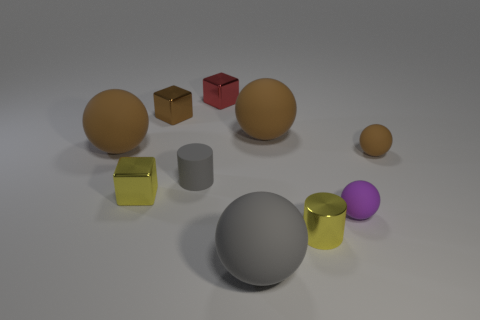There is a big ball that is in front of the small brown matte sphere; does it have the same color as the rubber cylinder?
Make the answer very short. Yes. Are there more tiny brown things on the right side of the yellow metal cylinder than purple rubber objects that are in front of the tiny purple matte ball?
Ensure brevity in your answer.  Yes. Are there any other things that have the same color as the small shiny cylinder?
Your answer should be compact. Yes. How many things are either shiny blocks or large gray matte spheres?
Ensure brevity in your answer.  4. Is the size of the yellow object right of the gray cylinder the same as the tiny brown ball?
Your response must be concise. Yes. How many other objects are there of the same size as the metal cylinder?
Offer a terse response. 6. Are there any large green rubber cubes?
Ensure brevity in your answer.  No. How big is the metallic cube that is in front of the thing that is to the right of the small purple matte thing?
Ensure brevity in your answer.  Small. Does the large ball that is to the left of the brown metallic thing have the same color as the big ball in front of the purple matte ball?
Provide a short and direct response. No. What color is the small rubber object that is right of the small gray thing and left of the small brown matte ball?
Provide a short and direct response. Purple. 